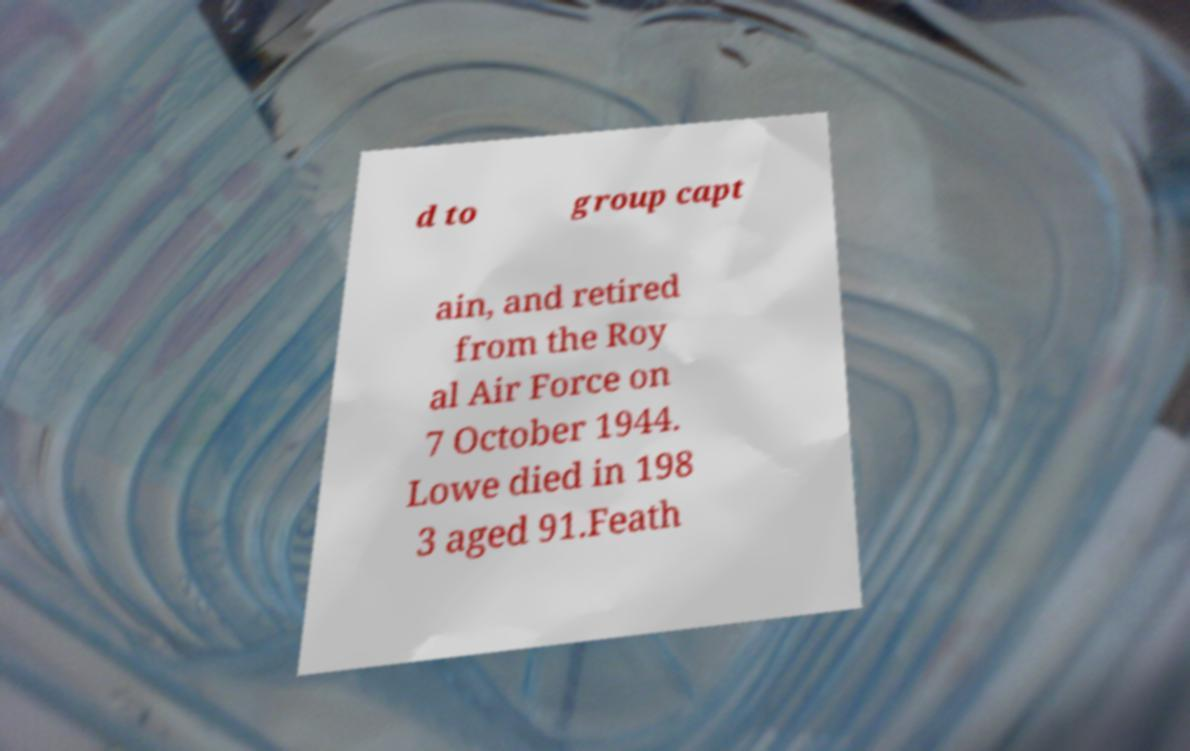Please identify and transcribe the text found in this image. d to group capt ain, and retired from the Roy al Air Force on 7 October 1944. Lowe died in 198 3 aged 91.Feath 